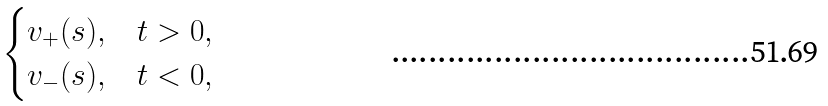<formula> <loc_0><loc_0><loc_500><loc_500>\begin{cases} v _ { + } ( s ) , & t > 0 , \\ v _ { - } ( s ) , & t < 0 , \end{cases}</formula> 